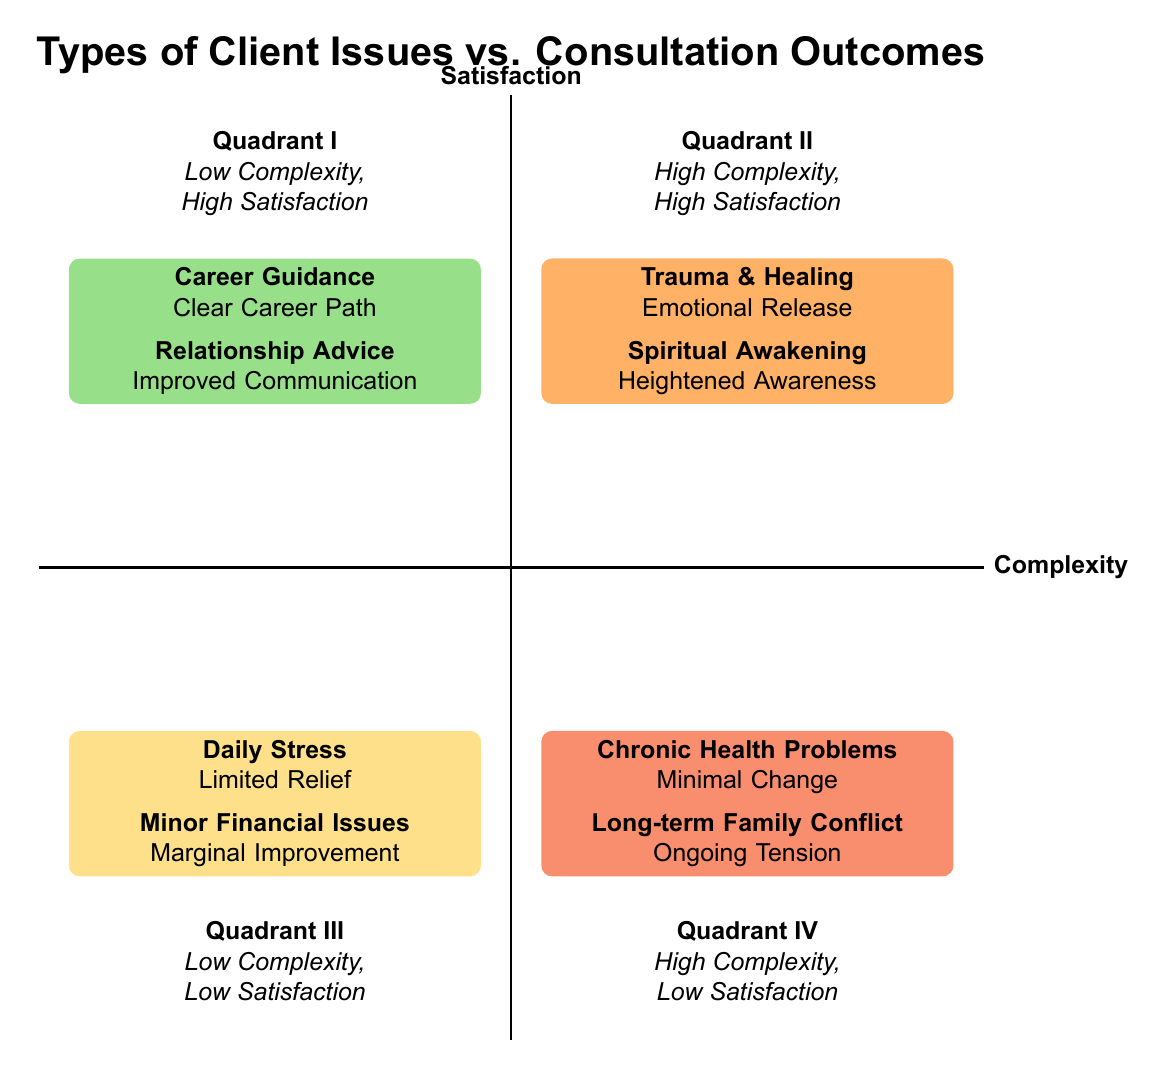What is the consultation outcome for "Career Guidance"? The diagram lists "Clear Career Path" as the consultation outcome for the issue "Career Guidance" in Quadrant I.
Answer: Clear Career Path How many issues are categorized as "High Complexity, High Satisfaction"? Quadrant II has two issues listed: "Trauma & Healing" and "Spiritual Awakening", which means there are a total of 2 issues in this category.
Answer: 2 Which quadrant deals with "Chronic Health Problems"? "Chronic Health Problems" is found in Quadrant IV, which is characterized by high complexity and low satisfaction.
Answer: Quadrant IV What is the general satisfaction level for issues in Quadrant III? Quadrant III is defined as having low satisfaction, meaning that the issues in this quadrant are associated with limited positive outcomes.
Answer: Low Satisfaction Is there an issue that yields a consultation outcome of "Ongoing Tension"? "Ongoing Tension" is the consultation outcome listed for the issue "Long-term Family Conflict", found in Quadrant IV.
Answer: Yes Which quadrant contains "Daily Stress"? The issue "Daily Stress" is found in Quadrant III, where it is noted for providing limited relief.
Answer: Quadrant III What type of client issues are resolved with "Emotional Release"? "Emotional Release" is the outcome associated with the issue "Trauma & Healing," which is in Quadrant II.
Answer: Trauma & Healing What is the relationship between "Long-term Family Conflict" and satisfaction? "Long-term Family Conflict" is in Quadrant IV, where the satisfaction level is low, indicating a lack of positive outcomes from consultations regarding this issue.
Answer: Low Satisfaction How many issues have a positive consultation outcome in Quadrant I? Quadrant I lists two issues: "Career Guidance" and "Relationship Advice," both of which have positive outcomes, thus the answer is 2.
Answer: 2 